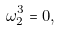<formula> <loc_0><loc_0><loc_500><loc_500>\omega _ { 2 } ^ { 3 } = 0 ,</formula> 